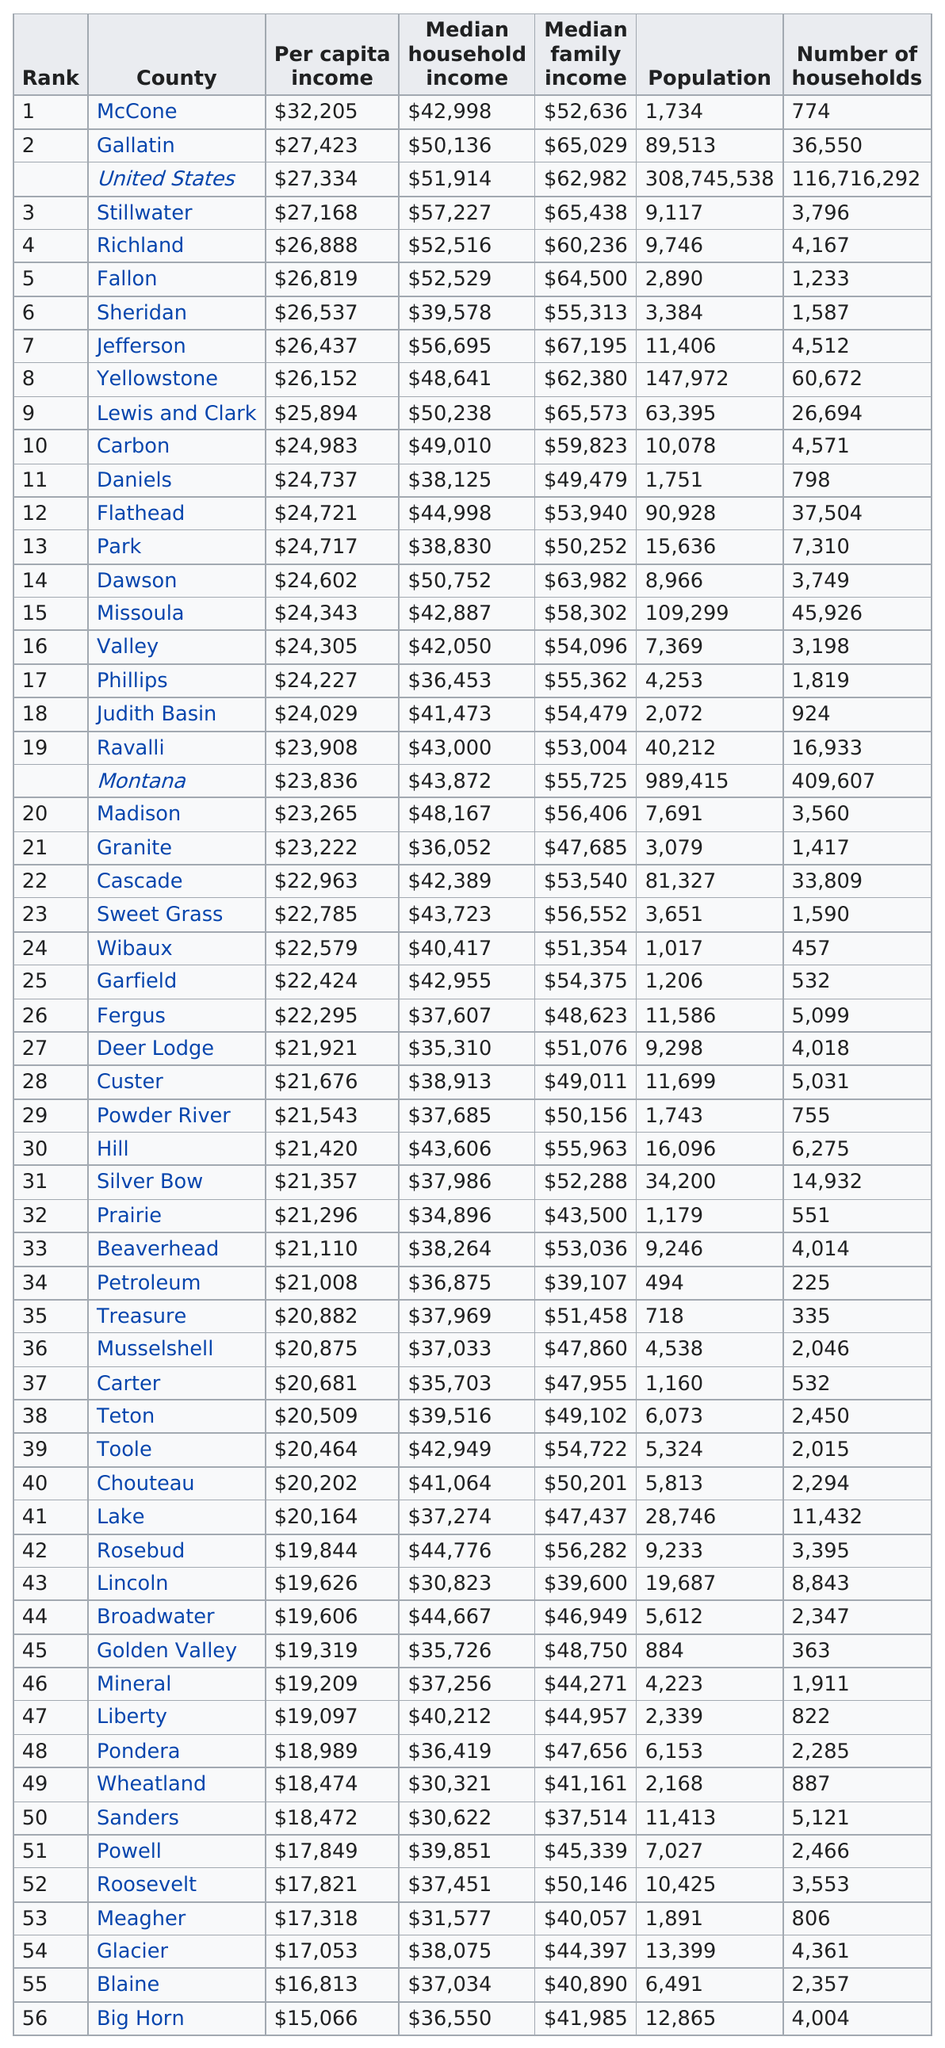Point out several critical features in this image. Lincoln is not higher than Toole on the chart. Fallon has more households than Phillips. When comparing the combined populations of Park and Missoula counties with Judith Basin and Madison counties, Park and Missoula counties have a larger population. The per capita income in Richland County is different from that of Sheridan County, with Richland County having a higher per capita income. Eight counties have a median household income of at least $50,000. 